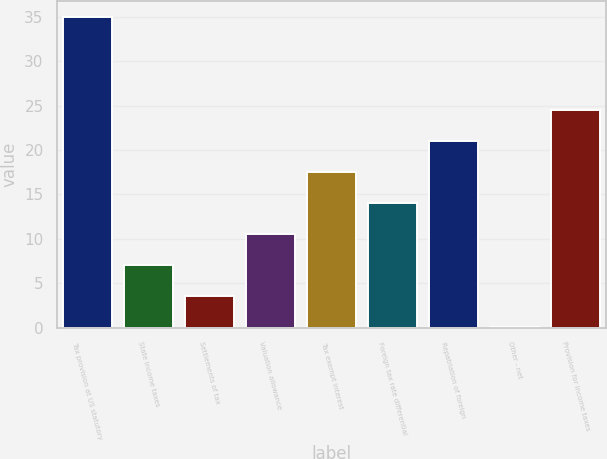<chart> <loc_0><loc_0><loc_500><loc_500><bar_chart><fcel>Tax provision at US statutory<fcel>State income taxes<fcel>Settlements of tax<fcel>Valuation allowance<fcel>Tax exempt interest<fcel>Foreign tax rate differential<fcel>Repatriation of foreign<fcel>Other - net<fcel>Provision for income taxes<nl><fcel>35<fcel>7.08<fcel>3.59<fcel>10.57<fcel>17.55<fcel>14.06<fcel>21.04<fcel>0.1<fcel>24.53<nl></chart> 